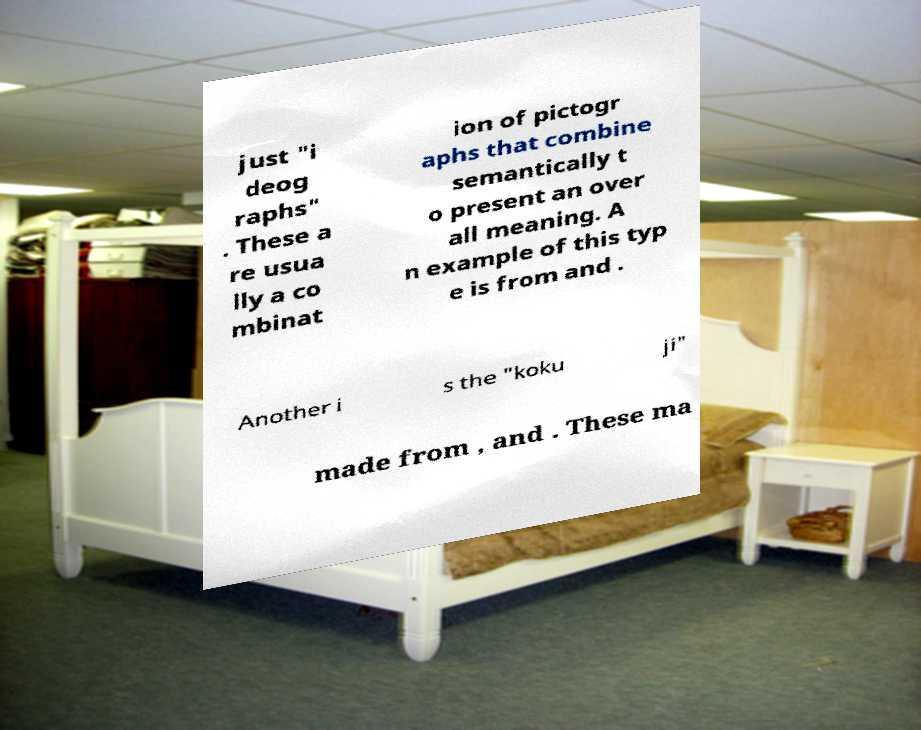Please read and relay the text visible in this image. What does it say? just "i deog raphs" . These a re usua lly a co mbinat ion of pictogr aphs that combine semantically t o present an over all meaning. A n example of this typ e is from and . Another i s the "koku ji" made from , and . These ma 